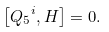<formula> <loc_0><loc_0><loc_500><loc_500>\left [ { Q _ { 5 } } ^ { i } , H \right ] = 0 .</formula> 